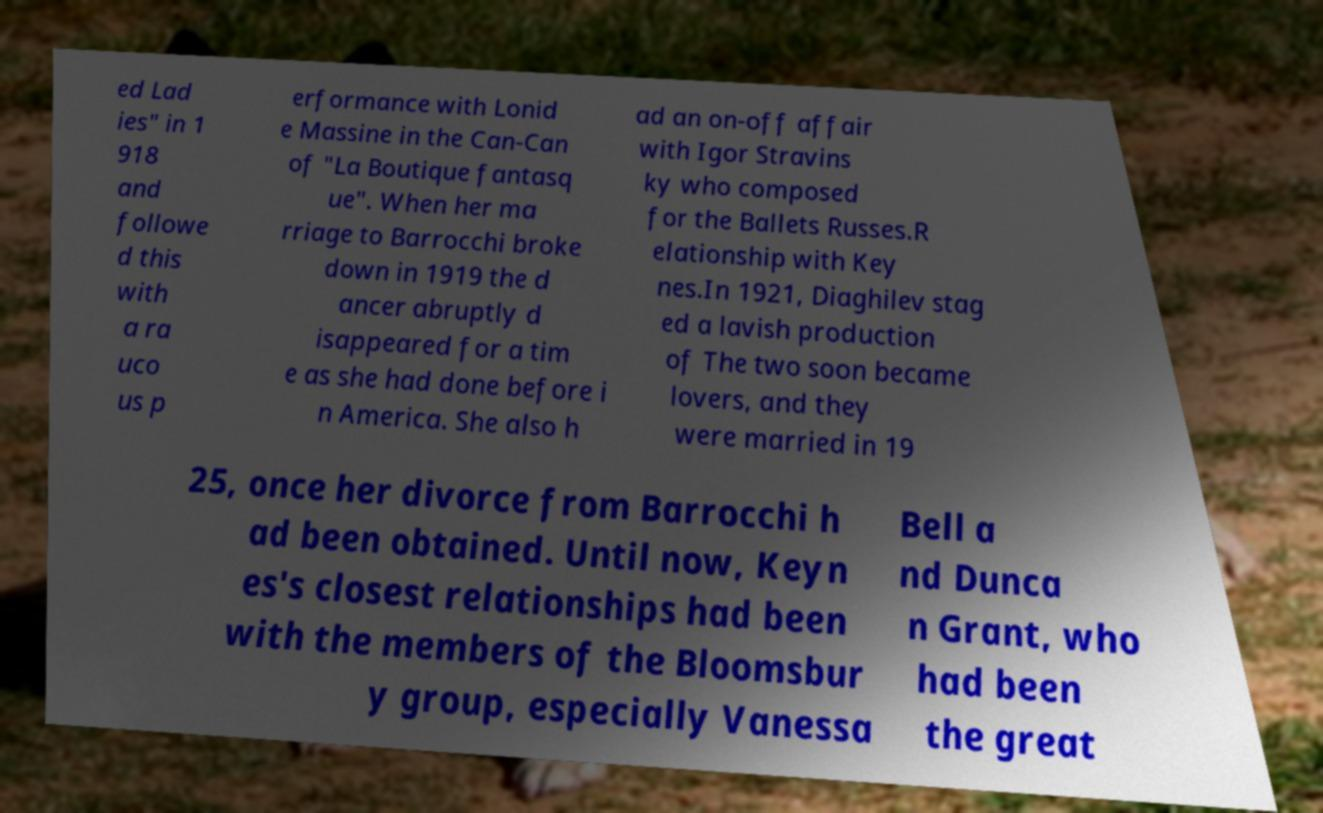Please read and relay the text visible in this image. What does it say? ed Lad ies" in 1 918 and followe d this with a ra uco us p erformance with Lonid e Massine in the Can-Can of "La Boutique fantasq ue". When her ma rriage to Barrocchi broke down in 1919 the d ancer abruptly d isappeared for a tim e as she had done before i n America. She also h ad an on-off affair with Igor Stravins ky who composed for the Ballets Russes.R elationship with Key nes.In 1921, Diaghilev stag ed a lavish production of The two soon became lovers, and they were married in 19 25, once her divorce from Barrocchi h ad been obtained. Until now, Keyn es's closest relationships had been with the members of the Bloomsbur y group, especially Vanessa Bell a nd Dunca n Grant, who had been the great 